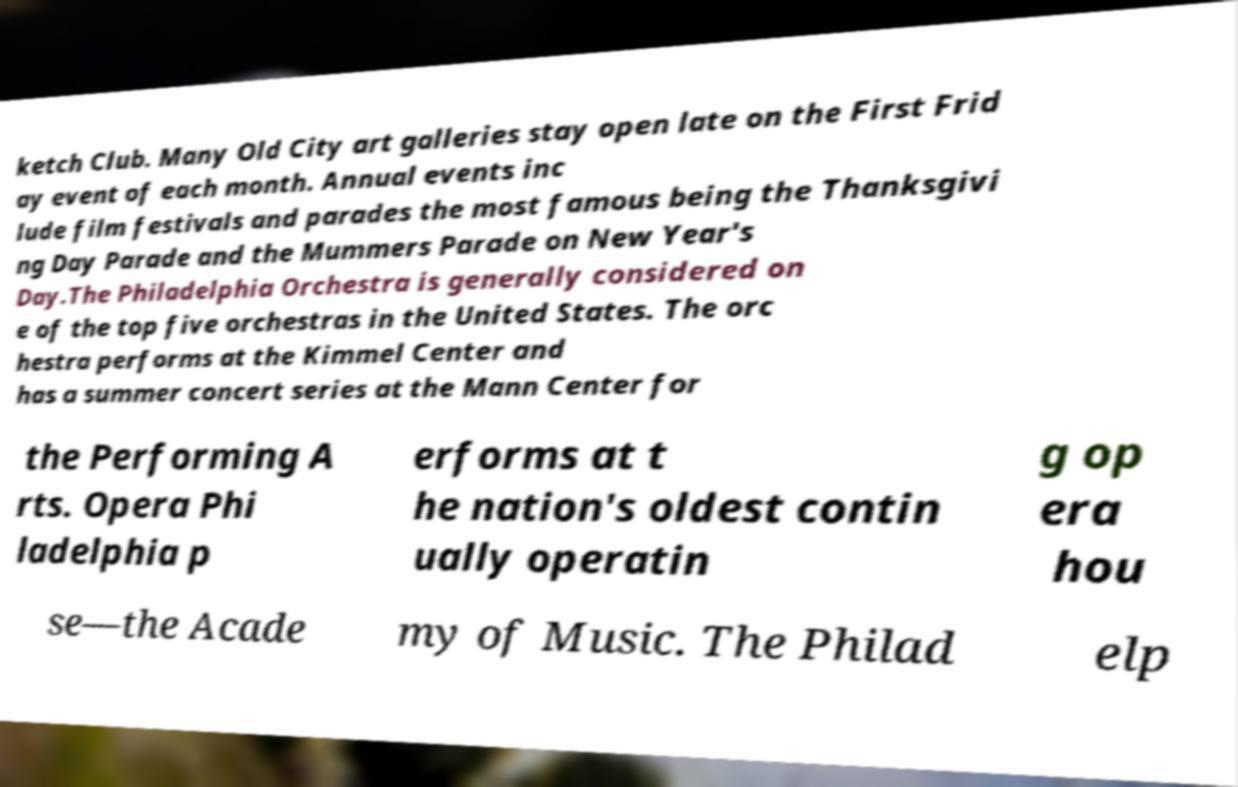Could you assist in decoding the text presented in this image and type it out clearly? ketch Club. Many Old City art galleries stay open late on the First Frid ay event of each month. Annual events inc lude film festivals and parades the most famous being the Thanksgivi ng Day Parade and the Mummers Parade on New Year's Day.The Philadelphia Orchestra is generally considered on e of the top five orchestras in the United States. The orc hestra performs at the Kimmel Center and has a summer concert series at the Mann Center for the Performing A rts. Opera Phi ladelphia p erforms at t he nation's oldest contin ually operatin g op era hou se—the Acade my of Music. The Philad elp 